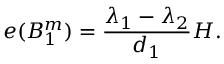<formula> <loc_0><loc_0><loc_500><loc_500>e ( B _ { 1 } ^ { m } ) = { \frac { \lambda _ { 1 } - \lambda _ { 2 } } { d _ { 1 } } } H .</formula> 